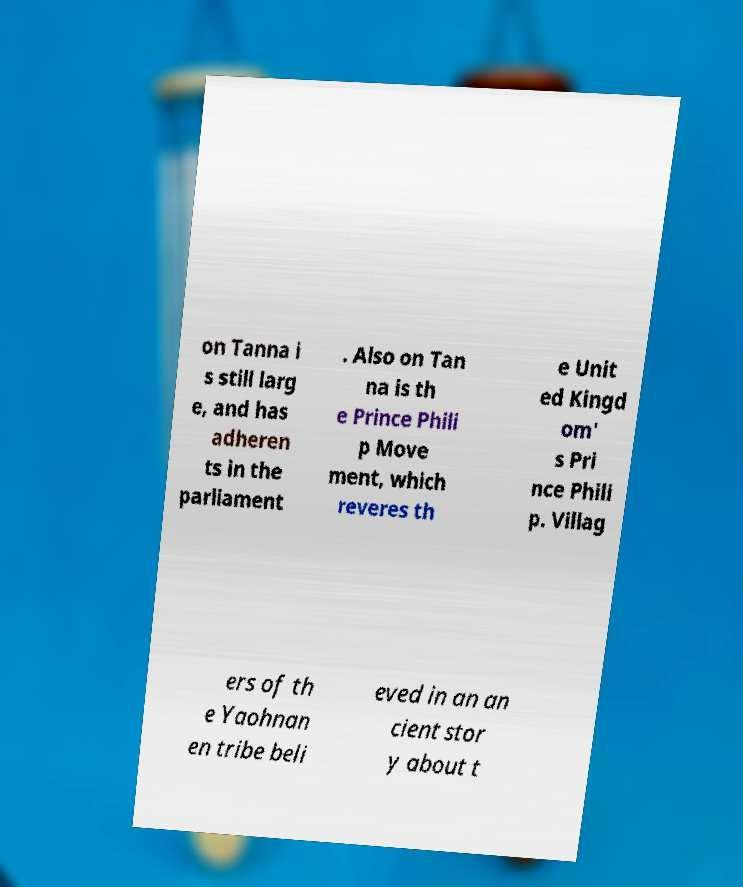Can you read and provide the text displayed in the image?This photo seems to have some interesting text. Can you extract and type it out for me? on Tanna i s still larg e, and has adheren ts in the parliament . Also on Tan na is th e Prince Phili p Move ment, which reveres th e Unit ed Kingd om' s Pri nce Phili p. Villag ers of th e Yaohnan en tribe beli eved in an an cient stor y about t 